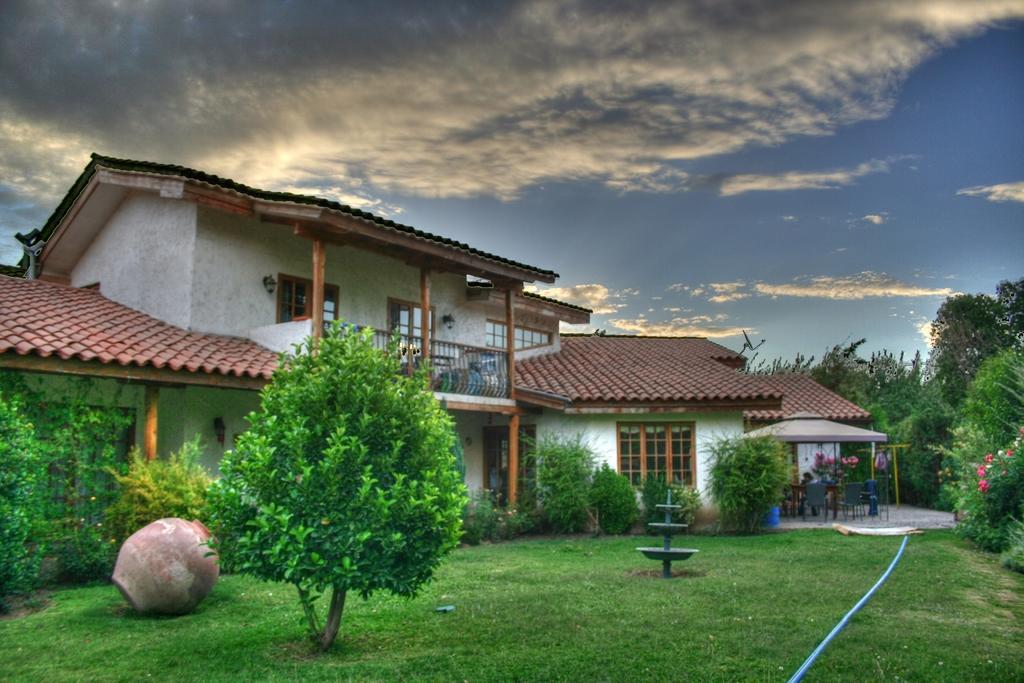How would you summarize this image in a sentence or two? In this image we can see buildings, grills, electric lights, bushes, trees, an empty pot on the ground, fountain and persons on the chairs under a parasol. In the background there are sky with clouds. 